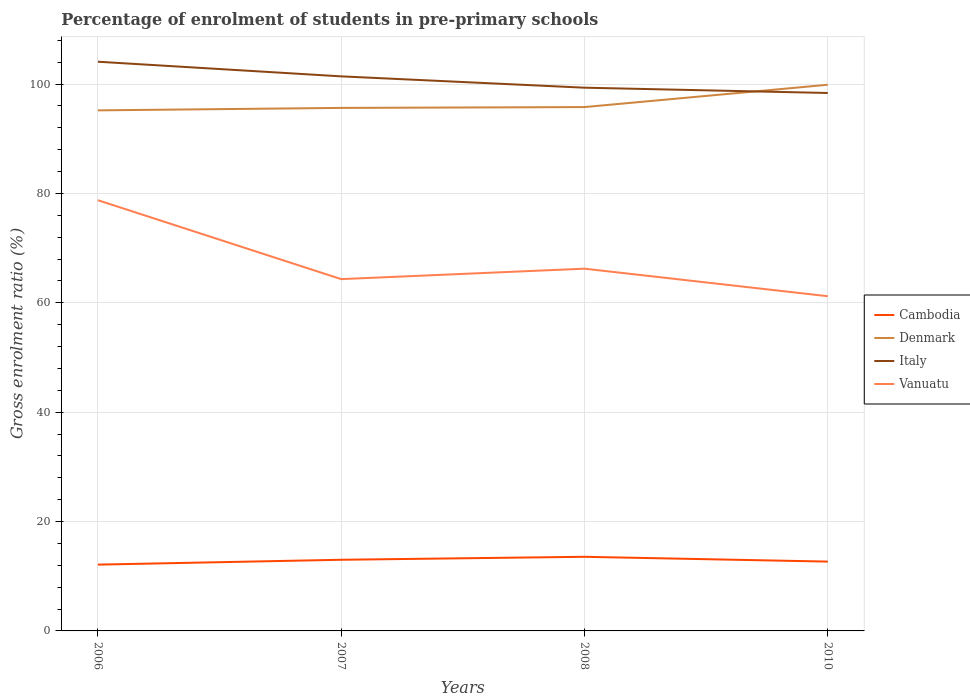Is the number of lines equal to the number of legend labels?
Offer a very short reply. Yes. Across all years, what is the maximum percentage of students enrolled in pre-primary schools in Italy?
Offer a very short reply. 98.38. In which year was the percentage of students enrolled in pre-primary schools in Vanuatu maximum?
Offer a very short reply. 2010. What is the total percentage of students enrolled in pre-primary schools in Denmark in the graph?
Provide a succinct answer. -0.15. What is the difference between the highest and the second highest percentage of students enrolled in pre-primary schools in Cambodia?
Offer a terse response. 1.43. What is the difference between the highest and the lowest percentage of students enrolled in pre-primary schools in Italy?
Make the answer very short. 2. Is the percentage of students enrolled in pre-primary schools in Cambodia strictly greater than the percentage of students enrolled in pre-primary schools in Denmark over the years?
Make the answer very short. Yes. What is the difference between two consecutive major ticks on the Y-axis?
Your answer should be very brief. 20. Are the values on the major ticks of Y-axis written in scientific E-notation?
Provide a short and direct response. No. Does the graph contain any zero values?
Give a very brief answer. No. Where does the legend appear in the graph?
Offer a very short reply. Center right. How many legend labels are there?
Offer a terse response. 4. How are the legend labels stacked?
Give a very brief answer. Vertical. What is the title of the graph?
Keep it short and to the point. Percentage of enrolment of students in pre-primary schools. What is the label or title of the X-axis?
Your response must be concise. Years. What is the Gross enrolment ratio (%) of Cambodia in 2006?
Give a very brief answer. 12.13. What is the Gross enrolment ratio (%) of Denmark in 2006?
Provide a short and direct response. 95.2. What is the Gross enrolment ratio (%) in Italy in 2006?
Give a very brief answer. 104.1. What is the Gross enrolment ratio (%) in Vanuatu in 2006?
Your answer should be compact. 78.77. What is the Gross enrolment ratio (%) in Cambodia in 2007?
Your answer should be compact. 13.01. What is the Gross enrolment ratio (%) in Denmark in 2007?
Your answer should be very brief. 95.65. What is the Gross enrolment ratio (%) in Italy in 2007?
Offer a very short reply. 101.42. What is the Gross enrolment ratio (%) of Vanuatu in 2007?
Offer a terse response. 64.34. What is the Gross enrolment ratio (%) in Cambodia in 2008?
Your answer should be very brief. 13.56. What is the Gross enrolment ratio (%) of Denmark in 2008?
Provide a succinct answer. 95.8. What is the Gross enrolment ratio (%) in Italy in 2008?
Offer a very short reply. 99.35. What is the Gross enrolment ratio (%) of Vanuatu in 2008?
Your answer should be very brief. 66.25. What is the Gross enrolment ratio (%) of Cambodia in 2010?
Make the answer very short. 12.68. What is the Gross enrolment ratio (%) in Denmark in 2010?
Keep it short and to the point. 99.88. What is the Gross enrolment ratio (%) of Italy in 2010?
Give a very brief answer. 98.38. What is the Gross enrolment ratio (%) of Vanuatu in 2010?
Your response must be concise. 61.21. Across all years, what is the maximum Gross enrolment ratio (%) in Cambodia?
Your answer should be very brief. 13.56. Across all years, what is the maximum Gross enrolment ratio (%) of Denmark?
Provide a succinct answer. 99.88. Across all years, what is the maximum Gross enrolment ratio (%) in Italy?
Ensure brevity in your answer.  104.1. Across all years, what is the maximum Gross enrolment ratio (%) in Vanuatu?
Provide a succinct answer. 78.77. Across all years, what is the minimum Gross enrolment ratio (%) in Cambodia?
Provide a succinct answer. 12.13. Across all years, what is the minimum Gross enrolment ratio (%) of Denmark?
Your answer should be very brief. 95.2. Across all years, what is the minimum Gross enrolment ratio (%) in Italy?
Your response must be concise. 98.38. Across all years, what is the minimum Gross enrolment ratio (%) of Vanuatu?
Keep it short and to the point. 61.21. What is the total Gross enrolment ratio (%) of Cambodia in the graph?
Offer a very short reply. 51.37. What is the total Gross enrolment ratio (%) in Denmark in the graph?
Your answer should be very brief. 386.54. What is the total Gross enrolment ratio (%) of Italy in the graph?
Your answer should be compact. 403.25. What is the total Gross enrolment ratio (%) in Vanuatu in the graph?
Your answer should be very brief. 270.57. What is the difference between the Gross enrolment ratio (%) in Cambodia in 2006 and that in 2007?
Give a very brief answer. -0.89. What is the difference between the Gross enrolment ratio (%) of Denmark in 2006 and that in 2007?
Make the answer very short. -0.45. What is the difference between the Gross enrolment ratio (%) in Italy in 2006 and that in 2007?
Your answer should be very brief. 2.68. What is the difference between the Gross enrolment ratio (%) in Vanuatu in 2006 and that in 2007?
Your answer should be very brief. 14.43. What is the difference between the Gross enrolment ratio (%) of Cambodia in 2006 and that in 2008?
Provide a short and direct response. -1.43. What is the difference between the Gross enrolment ratio (%) in Denmark in 2006 and that in 2008?
Give a very brief answer. -0.6. What is the difference between the Gross enrolment ratio (%) of Italy in 2006 and that in 2008?
Your answer should be very brief. 4.75. What is the difference between the Gross enrolment ratio (%) in Vanuatu in 2006 and that in 2008?
Keep it short and to the point. 12.52. What is the difference between the Gross enrolment ratio (%) of Cambodia in 2006 and that in 2010?
Offer a terse response. -0.55. What is the difference between the Gross enrolment ratio (%) of Denmark in 2006 and that in 2010?
Ensure brevity in your answer.  -4.68. What is the difference between the Gross enrolment ratio (%) in Italy in 2006 and that in 2010?
Your answer should be compact. 5.72. What is the difference between the Gross enrolment ratio (%) in Vanuatu in 2006 and that in 2010?
Your answer should be very brief. 17.56. What is the difference between the Gross enrolment ratio (%) in Cambodia in 2007 and that in 2008?
Your answer should be compact. -0.54. What is the difference between the Gross enrolment ratio (%) in Denmark in 2007 and that in 2008?
Provide a succinct answer. -0.15. What is the difference between the Gross enrolment ratio (%) in Italy in 2007 and that in 2008?
Keep it short and to the point. 2.07. What is the difference between the Gross enrolment ratio (%) of Vanuatu in 2007 and that in 2008?
Offer a terse response. -1.91. What is the difference between the Gross enrolment ratio (%) of Cambodia in 2007 and that in 2010?
Ensure brevity in your answer.  0.34. What is the difference between the Gross enrolment ratio (%) of Denmark in 2007 and that in 2010?
Offer a terse response. -4.23. What is the difference between the Gross enrolment ratio (%) in Italy in 2007 and that in 2010?
Offer a terse response. 3.04. What is the difference between the Gross enrolment ratio (%) in Vanuatu in 2007 and that in 2010?
Provide a short and direct response. 3.12. What is the difference between the Gross enrolment ratio (%) in Cambodia in 2008 and that in 2010?
Offer a terse response. 0.88. What is the difference between the Gross enrolment ratio (%) in Denmark in 2008 and that in 2010?
Give a very brief answer. -4.08. What is the difference between the Gross enrolment ratio (%) in Italy in 2008 and that in 2010?
Provide a short and direct response. 0.97. What is the difference between the Gross enrolment ratio (%) of Vanuatu in 2008 and that in 2010?
Your response must be concise. 5.03. What is the difference between the Gross enrolment ratio (%) of Cambodia in 2006 and the Gross enrolment ratio (%) of Denmark in 2007?
Provide a short and direct response. -83.53. What is the difference between the Gross enrolment ratio (%) of Cambodia in 2006 and the Gross enrolment ratio (%) of Italy in 2007?
Provide a short and direct response. -89.29. What is the difference between the Gross enrolment ratio (%) of Cambodia in 2006 and the Gross enrolment ratio (%) of Vanuatu in 2007?
Ensure brevity in your answer.  -52.21. What is the difference between the Gross enrolment ratio (%) of Denmark in 2006 and the Gross enrolment ratio (%) of Italy in 2007?
Offer a terse response. -6.22. What is the difference between the Gross enrolment ratio (%) of Denmark in 2006 and the Gross enrolment ratio (%) of Vanuatu in 2007?
Your response must be concise. 30.86. What is the difference between the Gross enrolment ratio (%) of Italy in 2006 and the Gross enrolment ratio (%) of Vanuatu in 2007?
Give a very brief answer. 39.76. What is the difference between the Gross enrolment ratio (%) in Cambodia in 2006 and the Gross enrolment ratio (%) in Denmark in 2008?
Your response must be concise. -83.68. What is the difference between the Gross enrolment ratio (%) in Cambodia in 2006 and the Gross enrolment ratio (%) in Italy in 2008?
Make the answer very short. -87.22. What is the difference between the Gross enrolment ratio (%) of Cambodia in 2006 and the Gross enrolment ratio (%) of Vanuatu in 2008?
Make the answer very short. -54.12. What is the difference between the Gross enrolment ratio (%) in Denmark in 2006 and the Gross enrolment ratio (%) in Italy in 2008?
Provide a short and direct response. -4.15. What is the difference between the Gross enrolment ratio (%) in Denmark in 2006 and the Gross enrolment ratio (%) in Vanuatu in 2008?
Your answer should be very brief. 28.95. What is the difference between the Gross enrolment ratio (%) in Italy in 2006 and the Gross enrolment ratio (%) in Vanuatu in 2008?
Your answer should be very brief. 37.85. What is the difference between the Gross enrolment ratio (%) in Cambodia in 2006 and the Gross enrolment ratio (%) in Denmark in 2010?
Your answer should be very brief. -87.76. What is the difference between the Gross enrolment ratio (%) of Cambodia in 2006 and the Gross enrolment ratio (%) of Italy in 2010?
Make the answer very short. -86.25. What is the difference between the Gross enrolment ratio (%) of Cambodia in 2006 and the Gross enrolment ratio (%) of Vanuatu in 2010?
Provide a short and direct response. -49.09. What is the difference between the Gross enrolment ratio (%) of Denmark in 2006 and the Gross enrolment ratio (%) of Italy in 2010?
Offer a very short reply. -3.18. What is the difference between the Gross enrolment ratio (%) of Denmark in 2006 and the Gross enrolment ratio (%) of Vanuatu in 2010?
Offer a terse response. 33.99. What is the difference between the Gross enrolment ratio (%) in Italy in 2006 and the Gross enrolment ratio (%) in Vanuatu in 2010?
Ensure brevity in your answer.  42.88. What is the difference between the Gross enrolment ratio (%) in Cambodia in 2007 and the Gross enrolment ratio (%) in Denmark in 2008?
Provide a short and direct response. -82.79. What is the difference between the Gross enrolment ratio (%) in Cambodia in 2007 and the Gross enrolment ratio (%) in Italy in 2008?
Your answer should be very brief. -86.33. What is the difference between the Gross enrolment ratio (%) of Cambodia in 2007 and the Gross enrolment ratio (%) of Vanuatu in 2008?
Offer a terse response. -53.23. What is the difference between the Gross enrolment ratio (%) in Denmark in 2007 and the Gross enrolment ratio (%) in Italy in 2008?
Offer a very short reply. -3.7. What is the difference between the Gross enrolment ratio (%) in Denmark in 2007 and the Gross enrolment ratio (%) in Vanuatu in 2008?
Ensure brevity in your answer.  29.4. What is the difference between the Gross enrolment ratio (%) of Italy in 2007 and the Gross enrolment ratio (%) of Vanuatu in 2008?
Give a very brief answer. 35.17. What is the difference between the Gross enrolment ratio (%) of Cambodia in 2007 and the Gross enrolment ratio (%) of Denmark in 2010?
Offer a very short reply. -86.87. What is the difference between the Gross enrolment ratio (%) in Cambodia in 2007 and the Gross enrolment ratio (%) in Italy in 2010?
Provide a succinct answer. -85.37. What is the difference between the Gross enrolment ratio (%) in Cambodia in 2007 and the Gross enrolment ratio (%) in Vanuatu in 2010?
Provide a short and direct response. -48.2. What is the difference between the Gross enrolment ratio (%) of Denmark in 2007 and the Gross enrolment ratio (%) of Italy in 2010?
Offer a very short reply. -2.73. What is the difference between the Gross enrolment ratio (%) of Denmark in 2007 and the Gross enrolment ratio (%) of Vanuatu in 2010?
Your answer should be very brief. 34.44. What is the difference between the Gross enrolment ratio (%) in Italy in 2007 and the Gross enrolment ratio (%) in Vanuatu in 2010?
Your answer should be compact. 40.21. What is the difference between the Gross enrolment ratio (%) in Cambodia in 2008 and the Gross enrolment ratio (%) in Denmark in 2010?
Your answer should be compact. -86.33. What is the difference between the Gross enrolment ratio (%) of Cambodia in 2008 and the Gross enrolment ratio (%) of Italy in 2010?
Offer a very short reply. -84.83. What is the difference between the Gross enrolment ratio (%) in Cambodia in 2008 and the Gross enrolment ratio (%) in Vanuatu in 2010?
Your response must be concise. -47.66. What is the difference between the Gross enrolment ratio (%) in Denmark in 2008 and the Gross enrolment ratio (%) in Italy in 2010?
Offer a very short reply. -2.58. What is the difference between the Gross enrolment ratio (%) of Denmark in 2008 and the Gross enrolment ratio (%) of Vanuatu in 2010?
Your answer should be compact. 34.59. What is the difference between the Gross enrolment ratio (%) of Italy in 2008 and the Gross enrolment ratio (%) of Vanuatu in 2010?
Offer a terse response. 38.13. What is the average Gross enrolment ratio (%) in Cambodia per year?
Provide a short and direct response. 12.84. What is the average Gross enrolment ratio (%) in Denmark per year?
Provide a succinct answer. 96.64. What is the average Gross enrolment ratio (%) in Italy per year?
Your answer should be compact. 100.81. What is the average Gross enrolment ratio (%) in Vanuatu per year?
Your answer should be compact. 67.64. In the year 2006, what is the difference between the Gross enrolment ratio (%) of Cambodia and Gross enrolment ratio (%) of Denmark?
Offer a very short reply. -83.08. In the year 2006, what is the difference between the Gross enrolment ratio (%) of Cambodia and Gross enrolment ratio (%) of Italy?
Make the answer very short. -91.97. In the year 2006, what is the difference between the Gross enrolment ratio (%) in Cambodia and Gross enrolment ratio (%) in Vanuatu?
Offer a very short reply. -66.65. In the year 2006, what is the difference between the Gross enrolment ratio (%) of Denmark and Gross enrolment ratio (%) of Italy?
Keep it short and to the point. -8.89. In the year 2006, what is the difference between the Gross enrolment ratio (%) in Denmark and Gross enrolment ratio (%) in Vanuatu?
Give a very brief answer. 16.43. In the year 2006, what is the difference between the Gross enrolment ratio (%) in Italy and Gross enrolment ratio (%) in Vanuatu?
Provide a succinct answer. 25.33. In the year 2007, what is the difference between the Gross enrolment ratio (%) of Cambodia and Gross enrolment ratio (%) of Denmark?
Your answer should be very brief. -82.64. In the year 2007, what is the difference between the Gross enrolment ratio (%) of Cambodia and Gross enrolment ratio (%) of Italy?
Your answer should be very brief. -88.41. In the year 2007, what is the difference between the Gross enrolment ratio (%) of Cambodia and Gross enrolment ratio (%) of Vanuatu?
Make the answer very short. -51.32. In the year 2007, what is the difference between the Gross enrolment ratio (%) of Denmark and Gross enrolment ratio (%) of Italy?
Offer a terse response. -5.77. In the year 2007, what is the difference between the Gross enrolment ratio (%) in Denmark and Gross enrolment ratio (%) in Vanuatu?
Keep it short and to the point. 31.31. In the year 2007, what is the difference between the Gross enrolment ratio (%) in Italy and Gross enrolment ratio (%) in Vanuatu?
Offer a very short reply. 37.08. In the year 2008, what is the difference between the Gross enrolment ratio (%) of Cambodia and Gross enrolment ratio (%) of Denmark?
Make the answer very short. -82.25. In the year 2008, what is the difference between the Gross enrolment ratio (%) of Cambodia and Gross enrolment ratio (%) of Italy?
Ensure brevity in your answer.  -85.79. In the year 2008, what is the difference between the Gross enrolment ratio (%) of Cambodia and Gross enrolment ratio (%) of Vanuatu?
Your answer should be very brief. -52.69. In the year 2008, what is the difference between the Gross enrolment ratio (%) in Denmark and Gross enrolment ratio (%) in Italy?
Make the answer very short. -3.55. In the year 2008, what is the difference between the Gross enrolment ratio (%) of Denmark and Gross enrolment ratio (%) of Vanuatu?
Your answer should be compact. 29.55. In the year 2008, what is the difference between the Gross enrolment ratio (%) in Italy and Gross enrolment ratio (%) in Vanuatu?
Your answer should be very brief. 33.1. In the year 2010, what is the difference between the Gross enrolment ratio (%) in Cambodia and Gross enrolment ratio (%) in Denmark?
Offer a terse response. -87.21. In the year 2010, what is the difference between the Gross enrolment ratio (%) in Cambodia and Gross enrolment ratio (%) in Italy?
Ensure brevity in your answer.  -85.7. In the year 2010, what is the difference between the Gross enrolment ratio (%) in Cambodia and Gross enrolment ratio (%) in Vanuatu?
Your answer should be compact. -48.54. In the year 2010, what is the difference between the Gross enrolment ratio (%) of Denmark and Gross enrolment ratio (%) of Italy?
Give a very brief answer. 1.5. In the year 2010, what is the difference between the Gross enrolment ratio (%) in Denmark and Gross enrolment ratio (%) in Vanuatu?
Give a very brief answer. 38.67. In the year 2010, what is the difference between the Gross enrolment ratio (%) of Italy and Gross enrolment ratio (%) of Vanuatu?
Your answer should be compact. 37.17. What is the ratio of the Gross enrolment ratio (%) in Cambodia in 2006 to that in 2007?
Ensure brevity in your answer.  0.93. What is the ratio of the Gross enrolment ratio (%) in Denmark in 2006 to that in 2007?
Give a very brief answer. 1. What is the ratio of the Gross enrolment ratio (%) of Italy in 2006 to that in 2007?
Provide a succinct answer. 1.03. What is the ratio of the Gross enrolment ratio (%) in Vanuatu in 2006 to that in 2007?
Your answer should be compact. 1.22. What is the ratio of the Gross enrolment ratio (%) in Cambodia in 2006 to that in 2008?
Offer a terse response. 0.89. What is the ratio of the Gross enrolment ratio (%) of Italy in 2006 to that in 2008?
Provide a succinct answer. 1.05. What is the ratio of the Gross enrolment ratio (%) of Vanuatu in 2006 to that in 2008?
Provide a succinct answer. 1.19. What is the ratio of the Gross enrolment ratio (%) of Cambodia in 2006 to that in 2010?
Give a very brief answer. 0.96. What is the ratio of the Gross enrolment ratio (%) in Denmark in 2006 to that in 2010?
Make the answer very short. 0.95. What is the ratio of the Gross enrolment ratio (%) of Italy in 2006 to that in 2010?
Give a very brief answer. 1.06. What is the ratio of the Gross enrolment ratio (%) in Vanuatu in 2006 to that in 2010?
Keep it short and to the point. 1.29. What is the ratio of the Gross enrolment ratio (%) in Cambodia in 2007 to that in 2008?
Provide a succinct answer. 0.96. What is the ratio of the Gross enrolment ratio (%) of Denmark in 2007 to that in 2008?
Ensure brevity in your answer.  1. What is the ratio of the Gross enrolment ratio (%) of Italy in 2007 to that in 2008?
Your response must be concise. 1.02. What is the ratio of the Gross enrolment ratio (%) of Vanuatu in 2007 to that in 2008?
Your answer should be very brief. 0.97. What is the ratio of the Gross enrolment ratio (%) of Cambodia in 2007 to that in 2010?
Make the answer very short. 1.03. What is the ratio of the Gross enrolment ratio (%) of Denmark in 2007 to that in 2010?
Make the answer very short. 0.96. What is the ratio of the Gross enrolment ratio (%) in Italy in 2007 to that in 2010?
Give a very brief answer. 1.03. What is the ratio of the Gross enrolment ratio (%) in Vanuatu in 2007 to that in 2010?
Provide a succinct answer. 1.05. What is the ratio of the Gross enrolment ratio (%) in Cambodia in 2008 to that in 2010?
Your answer should be compact. 1.07. What is the ratio of the Gross enrolment ratio (%) in Denmark in 2008 to that in 2010?
Provide a short and direct response. 0.96. What is the ratio of the Gross enrolment ratio (%) of Italy in 2008 to that in 2010?
Give a very brief answer. 1.01. What is the ratio of the Gross enrolment ratio (%) in Vanuatu in 2008 to that in 2010?
Your response must be concise. 1.08. What is the difference between the highest and the second highest Gross enrolment ratio (%) of Cambodia?
Give a very brief answer. 0.54. What is the difference between the highest and the second highest Gross enrolment ratio (%) in Denmark?
Make the answer very short. 4.08. What is the difference between the highest and the second highest Gross enrolment ratio (%) of Italy?
Your answer should be compact. 2.68. What is the difference between the highest and the second highest Gross enrolment ratio (%) in Vanuatu?
Your response must be concise. 12.52. What is the difference between the highest and the lowest Gross enrolment ratio (%) in Cambodia?
Make the answer very short. 1.43. What is the difference between the highest and the lowest Gross enrolment ratio (%) in Denmark?
Provide a short and direct response. 4.68. What is the difference between the highest and the lowest Gross enrolment ratio (%) in Italy?
Ensure brevity in your answer.  5.72. What is the difference between the highest and the lowest Gross enrolment ratio (%) of Vanuatu?
Keep it short and to the point. 17.56. 